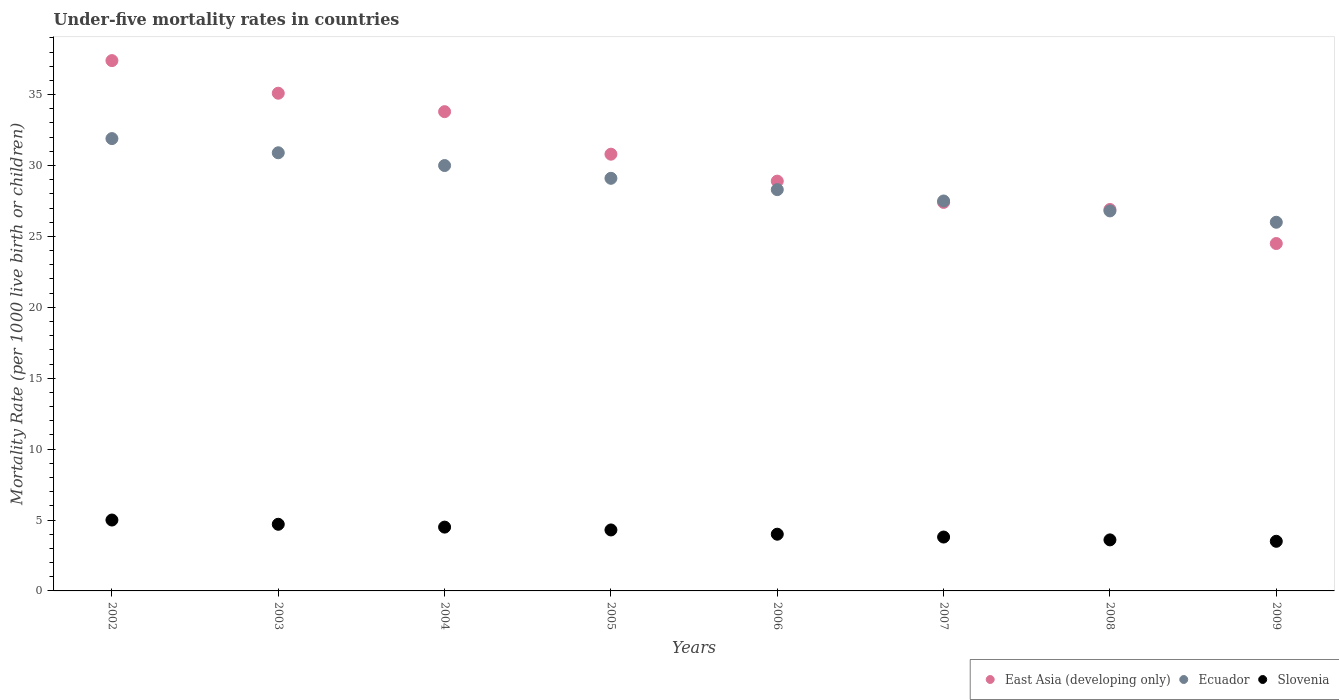How many different coloured dotlines are there?
Ensure brevity in your answer.  3. Is the number of dotlines equal to the number of legend labels?
Keep it short and to the point. Yes. What is the under-five mortality rate in East Asia (developing only) in 2002?
Your response must be concise. 37.4. Across all years, what is the maximum under-five mortality rate in Slovenia?
Offer a very short reply. 5. What is the total under-five mortality rate in Ecuador in the graph?
Offer a very short reply. 230.5. What is the difference between the under-five mortality rate in East Asia (developing only) in 2003 and that in 2005?
Your response must be concise. 4.3. What is the average under-five mortality rate in Ecuador per year?
Provide a succinct answer. 28.81. In the year 2006, what is the difference between the under-five mortality rate in East Asia (developing only) and under-five mortality rate in Slovenia?
Offer a very short reply. 24.9. In how many years, is the under-five mortality rate in East Asia (developing only) greater than 14?
Your response must be concise. 8. What is the ratio of the under-five mortality rate in Ecuador in 2002 to that in 2009?
Provide a succinct answer. 1.23. What is the difference between the highest and the second highest under-five mortality rate in Slovenia?
Give a very brief answer. 0.3. What is the difference between the highest and the lowest under-five mortality rate in Slovenia?
Make the answer very short. 1.5. Is the under-five mortality rate in Ecuador strictly less than the under-five mortality rate in East Asia (developing only) over the years?
Give a very brief answer. No. Are the values on the major ticks of Y-axis written in scientific E-notation?
Keep it short and to the point. No. Does the graph contain any zero values?
Make the answer very short. No. Does the graph contain grids?
Your response must be concise. No. How many legend labels are there?
Make the answer very short. 3. How are the legend labels stacked?
Your response must be concise. Horizontal. What is the title of the graph?
Ensure brevity in your answer.  Under-five mortality rates in countries. What is the label or title of the X-axis?
Your answer should be compact. Years. What is the label or title of the Y-axis?
Provide a short and direct response. Mortality Rate (per 1000 live birth or children). What is the Mortality Rate (per 1000 live birth or children) in East Asia (developing only) in 2002?
Your answer should be very brief. 37.4. What is the Mortality Rate (per 1000 live birth or children) of Ecuador in 2002?
Provide a short and direct response. 31.9. What is the Mortality Rate (per 1000 live birth or children) of East Asia (developing only) in 2003?
Ensure brevity in your answer.  35.1. What is the Mortality Rate (per 1000 live birth or children) of Ecuador in 2003?
Give a very brief answer. 30.9. What is the Mortality Rate (per 1000 live birth or children) in Slovenia in 2003?
Offer a terse response. 4.7. What is the Mortality Rate (per 1000 live birth or children) of East Asia (developing only) in 2004?
Your response must be concise. 33.8. What is the Mortality Rate (per 1000 live birth or children) of Slovenia in 2004?
Your response must be concise. 4.5. What is the Mortality Rate (per 1000 live birth or children) in East Asia (developing only) in 2005?
Offer a terse response. 30.8. What is the Mortality Rate (per 1000 live birth or children) of Ecuador in 2005?
Keep it short and to the point. 29.1. What is the Mortality Rate (per 1000 live birth or children) in East Asia (developing only) in 2006?
Your answer should be very brief. 28.9. What is the Mortality Rate (per 1000 live birth or children) of Ecuador in 2006?
Make the answer very short. 28.3. What is the Mortality Rate (per 1000 live birth or children) in East Asia (developing only) in 2007?
Offer a terse response. 27.4. What is the Mortality Rate (per 1000 live birth or children) in Ecuador in 2007?
Give a very brief answer. 27.5. What is the Mortality Rate (per 1000 live birth or children) of Slovenia in 2007?
Offer a very short reply. 3.8. What is the Mortality Rate (per 1000 live birth or children) of East Asia (developing only) in 2008?
Ensure brevity in your answer.  26.9. What is the Mortality Rate (per 1000 live birth or children) of Ecuador in 2008?
Ensure brevity in your answer.  26.8. What is the Mortality Rate (per 1000 live birth or children) in East Asia (developing only) in 2009?
Your answer should be compact. 24.5. Across all years, what is the maximum Mortality Rate (per 1000 live birth or children) of East Asia (developing only)?
Make the answer very short. 37.4. Across all years, what is the maximum Mortality Rate (per 1000 live birth or children) in Ecuador?
Provide a succinct answer. 31.9. Across all years, what is the minimum Mortality Rate (per 1000 live birth or children) of East Asia (developing only)?
Offer a very short reply. 24.5. What is the total Mortality Rate (per 1000 live birth or children) of East Asia (developing only) in the graph?
Ensure brevity in your answer.  244.8. What is the total Mortality Rate (per 1000 live birth or children) in Ecuador in the graph?
Ensure brevity in your answer.  230.5. What is the total Mortality Rate (per 1000 live birth or children) of Slovenia in the graph?
Your response must be concise. 33.4. What is the difference between the Mortality Rate (per 1000 live birth or children) in Slovenia in 2002 and that in 2003?
Provide a succinct answer. 0.3. What is the difference between the Mortality Rate (per 1000 live birth or children) in East Asia (developing only) in 2002 and that in 2004?
Your answer should be compact. 3.6. What is the difference between the Mortality Rate (per 1000 live birth or children) in Ecuador in 2002 and that in 2004?
Your answer should be very brief. 1.9. What is the difference between the Mortality Rate (per 1000 live birth or children) of Slovenia in 2002 and that in 2005?
Ensure brevity in your answer.  0.7. What is the difference between the Mortality Rate (per 1000 live birth or children) in Ecuador in 2002 and that in 2006?
Give a very brief answer. 3.6. What is the difference between the Mortality Rate (per 1000 live birth or children) of Slovenia in 2002 and that in 2006?
Provide a short and direct response. 1. What is the difference between the Mortality Rate (per 1000 live birth or children) of East Asia (developing only) in 2002 and that in 2007?
Provide a succinct answer. 10. What is the difference between the Mortality Rate (per 1000 live birth or children) in Ecuador in 2002 and that in 2007?
Your answer should be very brief. 4.4. What is the difference between the Mortality Rate (per 1000 live birth or children) of East Asia (developing only) in 2002 and that in 2008?
Your answer should be compact. 10.5. What is the difference between the Mortality Rate (per 1000 live birth or children) in Ecuador in 2002 and that in 2009?
Provide a short and direct response. 5.9. What is the difference between the Mortality Rate (per 1000 live birth or children) of Ecuador in 2003 and that in 2004?
Your answer should be compact. 0.9. What is the difference between the Mortality Rate (per 1000 live birth or children) of Slovenia in 2003 and that in 2005?
Provide a short and direct response. 0.4. What is the difference between the Mortality Rate (per 1000 live birth or children) in East Asia (developing only) in 2003 and that in 2006?
Make the answer very short. 6.2. What is the difference between the Mortality Rate (per 1000 live birth or children) in Ecuador in 2003 and that in 2006?
Provide a succinct answer. 2.6. What is the difference between the Mortality Rate (per 1000 live birth or children) in Slovenia in 2003 and that in 2006?
Your answer should be very brief. 0.7. What is the difference between the Mortality Rate (per 1000 live birth or children) of East Asia (developing only) in 2003 and that in 2007?
Offer a terse response. 7.7. What is the difference between the Mortality Rate (per 1000 live birth or children) of Slovenia in 2003 and that in 2007?
Keep it short and to the point. 0.9. What is the difference between the Mortality Rate (per 1000 live birth or children) of East Asia (developing only) in 2003 and that in 2008?
Make the answer very short. 8.2. What is the difference between the Mortality Rate (per 1000 live birth or children) of Slovenia in 2003 and that in 2008?
Your answer should be compact. 1.1. What is the difference between the Mortality Rate (per 1000 live birth or children) in Ecuador in 2003 and that in 2009?
Your response must be concise. 4.9. What is the difference between the Mortality Rate (per 1000 live birth or children) of East Asia (developing only) in 2004 and that in 2005?
Your answer should be very brief. 3. What is the difference between the Mortality Rate (per 1000 live birth or children) of Slovenia in 2004 and that in 2005?
Offer a terse response. 0.2. What is the difference between the Mortality Rate (per 1000 live birth or children) in East Asia (developing only) in 2004 and that in 2006?
Your response must be concise. 4.9. What is the difference between the Mortality Rate (per 1000 live birth or children) in Ecuador in 2004 and that in 2006?
Your answer should be compact. 1.7. What is the difference between the Mortality Rate (per 1000 live birth or children) in Ecuador in 2004 and that in 2007?
Provide a short and direct response. 2.5. What is the difference between the Mortality Rate (per 1000 live birth or children) in East Asia (developing only) in 2004 and that in 2008?
Offer a very short reply. 6.9. What is the difference between the Mortality Rate (per 1000 live birth or children) in Ecuador in 2004 and that in 2008?
Your answer should be very brief. 3.2. What is the difference between the Mortality Rate (per 1000 live birth or children) of Slovenia in 2004 and that in 2009?
Offer a terse response. 1. What is the difference between the Mortality Rate (per 1000 live birth or children) in Slovenia in 2005 and that in 2006?
Your answer should be compact. 0.3. What is the difference between the Mortality Rate (per 1000 live birth or children) in East Asia (developing only) in 2005 and that in 2008?
Your answer should be compact. 3.9. What is the difference between the Mortality Rate (per 1000 live birth or children) of Slovenia in 2005 and that in 2008?
Provide a short and direct response. 0.7. What is the difference between the Mortality Rate (per 1000 live birth or children) in East Asia (developing only) in 2005 and that in 2009?
Your response must be concise. 6.3. What is the difference between the Mortality Rate (per 1000 live birth or children) of Slovenia in 2005 and that in 2009?
Offer a very short reply. 0.8. What is the difference between the Mortality Rate (per 1000 live birth or children) of Slovenia in 2006 and that in 2007?
Your answer should be very brief. 0.2. What is the difference between the Mortality Rate (per 1000 live birth or children) in Ecuador in 2006 and that in 2008?
Offer a terse response. 1.5. What is the difference between the Mortality Rate (per 1000 live birth or children) of East Asia (developing only) in 2006 and that in 2009?
Give a very brief answer. 4.4. What is the difference between the Mortality Rate (per 1000 live birth or children) in Ecuador in 2007 and that in 2009?
Your answer should be compact. 1.5. What is the difference between the Mortality Rate (per 1000 live birth or children) in Slovenia in 2007 and that in 2009?
Give a very brief answer. 0.3. What is the difference between the Mortality Rate (per 1000 live birth or children) of East Asia (developing only) in 2008 and that in 2009?
Give a very brief answer. 2.4. What is the difference between the Mortality Rate (per 1000 live birth or children) in Slovenia in 2008 and that in 2009?
Your answer should be compact. 0.1. What is the difference between the Mortality Rate (per 1000 live birth or children) of East Asia (developing only) in 2002 and the Mortality Rate (per 1000 live birth or children) of Slovenia in 2003?
Provide a succinct answer. 32.7. What is the difference between the Mortality Rate (per 1000 live birth or children) of Ecuador in 2002 and the Mortality Rate (per 1000 live birth or children) of Slovenia in 2003?
Provide a succinct answer. 27.2. What is the difference between the Mortality Rate (per 1000 live birth or children) of East Asia (developing only) in 2002 and the Mortality Rate (per 1000 live birth or children) of Slovenia in 2004?
Ensure brevity in your answer.  32.9. What is the difference between the Mortality Rate (per 1000 live birth or children) in Ecuador in 2002 and the Mortality Rate (per 1000 live birth or children) in Slovenia in 2004?
Keep it short and to the point. 27.4. What is the difference between the Mortality Rate (per 1000 live birth or children) in East Asia (developing only) in 2002 and the Mortality Rate (per 1000 live birth or children) in Ecuador in 2005?
Your answer should be very brief. 8.3. What is the difference between the Mortality Rate (per 1000 live birth or children) of East Asia (developing only) in 2002 and the Mortality Rate (per 1000 live birth or children) of Slovenia in 2005?
Keep it short and to the point. 33.1. What is the difference between the Mortality Rate (per 1000 live birth or children) in Ecuador in 2002 and the Mortality Rate (per 1000 live birth or children) in Slovenia in 2005?
Offer a very short reply. 27.6. What is the difference between the Mortality Rate (per 1000 live birth or children) in East Asia (developing only) in 2002 and the Mortality Rate (per 1000 live birth or children) in Ecuador in 2006?
Offer a very short reply. 9.1. What is the difference between the Mortality Rate (per 1000 live birth or children) in East Asia (developing only) in 2002 and the Mortality Rate (per 1000 live birth or children) in Slovenia in 2006?
Your response must be concise. 33.4. What is the difference between the Mortality Rate (per 1000 live birth or children) of Ecuador in 2002 and the Mortality Rate (per 1000 live birth or children) of Slovenia in 2006?
Provide a short and direct response. 27.9. What is the difference between the Mortality Rate (per 1000 live birth or children) in East Asia (developing only) in 2002 and the Mortality Rate (per 1000 live birth or children) in Slovenia in 2007?
Your answer should be very brief. 33.6. What is the difference between the Mortality Rate (per 1000 live birth or children) in Ecuador in 2002 and the Mortality Rate (per 1000 live birth or children) in Slovenia in 2007?
Your response must be concise. 28.1. What is the difference between the Mortality Rate (per 1000 live birth or children) of East Asia (developing only) in 2002 and the Mortality Rate (per 1000 live birth or children) of Slovenia in 2008?
Offer a terse response. 33.8. What is the difference between the Mortality Rate (per 1000 live birth or children) in Ecuador in 2002 and the Mortality Rate (per 1000 live birth or children) in Slovenia in 2008?
Make the answer very short. 28.3. What is the difference between the Mortality Rate (per 1000 live birth or children) in East Asia (developing only) in 2002 and the Mortality Rate (per 1000 live birth or children) in Ecuador in 2009?
Make the answer very short. 11.4. What is the difference between the Mortality Rate (per 1000 live birth or children) in East Asia (developing only) in 2002 and the Mortality Rate (per 1000 live birth or children) in Slovenia in 2009?
Provide a succinct answer. 33.9. What is the difference between the Mortality Rate (per 1000 live birth or children) of Ecuador in 2002 and the Mortality Rate (per 1000 live birth or children) of Slovenia in 2009?
Give a very brief answer. 28.4. What is the difference between the Mortality Rate (per 1000 live birth or children) of East Asia (developing only) in 2003 and the Mortality Rate (per 1000 live birth or children) of Slovenia in 2004?
Provide a succinct answer. 30.6. What is the difference between the Mortality Rate (per 1000 live birth or children) in Ecuador in 2003 and the Mortality Rate (per 1000 live birth or children) in Slovenia in 2004?
Offer a terse response. 26.4. What is the difference between the Mortality Rate (per 1000 live birth or children) of East Asia (developing only) in 2003 and the Mortality Rate (per 1000 live birth or children) of Slovenia in 2005?
Provide a succinct answer. 30.8. What is the difference between the Mortality Rate (per 1000 live birth or children) of Ecuador in 2003 and the Mortality Rate (per 1000 live birth or children) of Slovenia in 2005?
Give a very brief answer. 26.6. What is the difference between the Mortality Rate (per 1000 live birth or children) in East Asia (developing only) in 2003 and the Mortality Rate (per 1000 live birth or children) in Slovenia in 2006?
Keep it short and to the point. 31.1. What is the difference between the Mortality Rate (per 1000 live birth or children) of Ecuador in 2003 and the Mortality Rate (per 1000 live birth or children) of Slovenia in 2006?
Keep it short and to the point. 26.9. What is the difference between the Mortality Rate (per 1000 live birth or children) of East Asia (developing only) in 2003 and the Mortality Rate (per 1000 live birth or children) of Slovenia in 2007?
Make the answer very short. 31.3. What is the difference between the Mortality Rate (per 1000 live birth or children) in Ecuador in 2003 and the Mortality Rate (per 1000 live birth or children) in Slovenia in 2007?
Your answer should be very brief. 27.1. What is the difference between the Mortality Rate (per 1000 live birth or children) in East Asia (developing only) in 2003 and the Mortality Rate (per 1000 live birth or children) in Ecuador in 2008?
Your answer should be very brief. 8.3. What is the difference between the Mortality Rate (per 1000 live birth or children) of East Asia (developing only) in 2003 and the Mortality Rate (per 1000 live birth or children) of Slovenia in 2008?
Provide a succinct answer. 31.5. What is the difference between the Mortality Rate (per 1000 live birth or children) in Ecuador in 2003 and the Mortality Rate (per 1000 live birth or children) in Slovenia in 2008?
Provide a succinct answer. 27.3. What is the difference between the Mortality Rate (per 1000 live birth or children) in East Asia (developing only) in 2003 and the Mortality Rate (per 1000 live birth or children) in Ecuador in 2009?
Ensure brevity in your answer.  9.1. What is the difference between the Mortality Rate (per 1000 live birth or children) of East Asia (developing only) in 2003 and the Mortality Rate (per 1000 live birth or children) of Slovenia in 2009?
Ensure brevity in your answer.  31.6. What is the difference between the Mortality Rate (per 1000 live birth or children) of Ecuador in 2003 and the Mortality Rate (per 1000 live birth or children) of Slovenia in 2009?
Ensure brevity in your answer.  27.4. What is the difference between the Mortality Rate (per 1000 live birth or children) in East Asia (developing only) in 2004 and the Mortality Rate (per 1000 live birth or children) in Slovenia in 2005?
Give a very brief answer. 29.5. What is the difference between the Mortality Rate (per 1000 live birth or children) of Ecuador in 2004 and the Mortality Rate (per 1000 live birth or children) of Slovenia in 2005?
Your answer should be compact. 25.7. What is the difference between the Mortality Rate (per 1000 live birth or children) in East Asia (developing only) in 2004 and the Mortality Rate (per 1000 live birth or children) in Slovenia in 2006?
Keep it short and to the point. 29.8. What is the difference between the Mortality Rate (per 1000 live birth or children) of Ecuador in 2004 and the Mortality Rate (per 1000 live birth or children) of Slovenia in 2006?
Provide a short and direct response. 26. What is the difference between the Mortality Rate (per 1000 live birth or children) of East Asia (developing only) in 2004 and the Mortality Rate (per 1000 live birth or children) of Slovenia in 2007?
Give a very brief answer. 30. What is the difference between the Mortality Rate (per 1000 live birth or children) of Ecuador in 2004 and the Mortality Rate (per 1000 live birth or children) of Slovenia in 2007?
Your answer should be very brief. 26.2. What is the difference between the Mortality Rate (per 1000 live birth or children) in East Asia (developing only) in 2004 and the Mortality Rate (per 1000 live birth or children) in Ecuador in 2008?
Offer a very short reply. 7. What is the difference between the Mortality Rate (per 1000 live birth or children) of East Asia (developing only) in 2004 and the Mortality Rate (per 1000 live birth or children) of Slovenia in 2008?
Offer a terse response. 30.2. What is the difference between the Mortality Rate (per 1000 live birth or children) of Ecuador in 2004 and the Mortality Rate (per 1000 live birth or children) of Slovenia in 2008?
Provide a succinct answer. 26.4. What is the difference between the Mortality Rate (per 1000 live birth or children) of East Asia (developing only) in 2004 and the Mortality Rate (per 1000 live birth or children) of Slovenia in 2009?
Offer a terse response. 30.3. What is the difference between the Mortality Rate (per 1000 live birth or children) of East Asia (developing only) in 2005 and the Mortality Rate (per 1000 live birth or children) of Slovenia in 2006?
Give a very brief answer. 26.8. What is the difference between the Mortality Rate (per 1000 live birth or children) in Ecuador in 2005 and the Mortality Rate (per 1000 live birth or children) in Slovenia in 2006?
Offer a very short reply. 25.1. What is the difference between the Mortality Rate (per 1000 live birth or children) of East Asia (developing only) in 2005 and the Mortality Rate (per 1000 live birth or children) of Slovenia in 2007?
Give a very brief answer. 27. What is the difference between the Mortality Rate (per 1000 live birth or children) of Ecuador in 2005 and the Mortality Rate (per 1000 live birth or children) of Slovenia in 2007?
Give a very brief answer. 25.3. What is the difference between the Mortality Rate (per 1000 live birth or children) of East Asia (developing only) in 2005 and the Mortality Rate (per 1000 live birth or children) of Slovenia in 2008?
Your answer should be compact. 27.2. What is the difference between the Mortality Rate (per 1000 live birth or children) of East Asia (developing only) in 2005 and the Mortality Rate (per 1000 live birth or children) of Slovenia in 2009?
Give a very brief answer. 27.3. What is the difference between the Mortality Rate (per 1000 live birth or children) of Ecuador in 2005 and the Mortality Rate (per 1000 live birth or children) of Slovenia in 2009?
Ensure brevity in your answer.  25.6. What is the difference between the Mortality Rate (per 1000 live birth or children) in East Asia (developing only) in 2006 and the Mortality Rate (per 1000 live birth or children) in Slovenia in 2007?
Offer a terse response. 25.1. What is the difference between the Mortality Rate (per 1000 live birth or children) of Ecuador in 2006 and the Mortality Rate (per 1000 live birth or children) of Slovenia in 2007?
Keep it short and to the point. 24.5. What is the difference between the Mortality Rate (per 1000 live birth or children) in East Asia (developing only) in 2006 and the Mortality Rate (per 1000 live birth or children) in Ecuador in 2008?
Ensure brevity in your answer.  2.1. What is the difference between the Mortality Rate (per 1000 live birth or children) in East Asia (developing only) in 2006 and the Mortality Rate (per 1000 live birth or children) in Slovenia in 2008?
Make the answer very short. 25.3. What is the difference between the Mortality Rate (per 1000 live birth or children) in Ecuador in 2006 and the Mortality Rate (per 1000 live birth or children) in Slovenia in 2008?
Make the answer very short. 24.7. What is the difference between the Mortality Rate (per 1000 live birth or children) of East Asia (developing only) in 2006 and the Mortality Rate (per 1000 live birth or children) of Slovenia in 2009?
Offer a terse response. 25.4. What is the difference between the Mortality Rate (per 1000 live birth or children) in Ecuador in 2006 and the Mortality Rate (per 1000 live birth or children) in Slovenia in 2009?
Provide a succinct answer. 24.8. What is the difference between the Mortality Rate (per 1000 live birth or children) in East Asia (developing only) in 2007 and the Mortality Rate (per 1000 live birth or children) in Slovenia in 2008?
Your answer should be very brief. 23.8. What is the difference between the Mortality Rate (per 1000 live birth or children) of Ecuador in 2007 and the Mortality Rate (per 1000 live birth or children) of Slovenia in 2008?
Ensure brevity in your answer.  23.9. What is the difference between the Mortality Rate (per 1000 live birth or children) in East Asia (developing only) in 2007 and the Mortality Rate (per 1000 live birth or children) in Ecuador in 2009?
Provide a short and direct response. 1.4. What is the difference between the Mortality Rate (per 1000 live birth or children) of East Asia (developing only) in 2007 and the Mortality Rate (per 1000 live birth or children) of Slovenia in 2009?
Keep it short and to the point. 23.9. What is the difference between the Mortality Rate (per 1000 live birth or children) of East Asia (developing only) in 2008 and the Mortality Rate (per 1000 live birth or children) of Ecuador in 2009?
Ensure brevity in your answer.  0.9. What is the difference between the Mortality Rate (per 1000 live birth or children) in East Asia (developing only) in 2008 and the Mortality Rate (per 1000 live birth or children) in Slovenia in 2009?
Your response must be concise. 23.4. What is the difference between the Mortality Rate (per 1000 live birth or children) of Ecuador in 2008 and the Mortality Rate (per 1000 live birth or children) of Slovenia in 2009?
Provide a succinct answer. 23.3. What is the average Mortality Rate (per 1000 live birth or children) in East Asia (developing only) per year?
Offer a very short reply. 30.6. What is the average Mortality Rate (per 1000 live birth or children) in Ecuador per year?
Give a very brief answer. 28.81. What is the average Mortality Rate (per 1000 live birth or children) in Slovenia per year?
Your answer should be compact. 4.17. In the year 2002, what is the difference between the Mortality Rate (per 1000 live birth or children) of East Asia (developing only) and Mortality Rate (per 1000 live birth or children) of Slovenia?
Your answer should be very brief. 32.4. In the year 2002, what is the difference between the Mortality Rate (per 1000 live birth or children) in Ecuador and Mortality Rate (per 1000 live birth or children) in Slovenia?
Your response must be concise. 26.9. In the year 2003, what is the difference between the Mortality Rate (per 1000 live birth or children) of East Asia (developing only) and Mortality Rate (per 1000 live birth or children) of Slovenia?
Your response must be concise. 30.4. In the year 2003, what is the difference between the Mortality Rate (per 1000 live birth or children) in Ecuador and Mortality Rate (per 1000 live birth or children) in Slovenia?
Make the answer very short. 26.2. In the year 2004, what is the difference between the Mortality Rate (per 1000 live birth or children) of East Asia (developing only) and Mortality Rate (per 1000 live birth or children) of Slovenia?
Keep it short and to the point. 29.3. In the year 2005, what is the difference between the Mortality Rate (per 1000 live birth or children) in East Asia (developing only) and Mortality Rate (per 1000 live birth or children) in Ecuador?
Your answer should be very brief. 1.7. In the year 2005, what is the difference between the Mortality Rate (per 1000 live birth or children) in Ecuador and Mortality Rate (per 1000 live birth or children) in Slovenia?
Ensure brevity in your answer.  24.8. In the year 2006, what is the difference between the Mortality Rate (per 1000 live birth or children) of East Asia (developing only) and Mortality Rate (per 1000 live birth or children) of Ecuador?
Ensure brevity in your answer.  0.6. In the year 2006, what is the difference between the Mortality Rate (per 1000 live birth or children) in East Asia (developing only) and Mortality Rate (per 1000 live birth or children) in Slovenia?
Offer a terse response. 24.9. In the year 2006, what is the difference between the Mortality Rate (per 1000 live birth or children) in Ecuador and Mortality Rate (per 1000 live birth or children) in Slovenia?
Ensure brevity in your answer.  24.3. In the year 2007, what is the difference between the Mortality Rate (per 1000 live birth or children) in East Asia (developing only) and Mortality Rate (per 1000 live birth or children) in Ecuador?
Give a very brief answer. -0.1. In the year 2007, what is the difference between the Mortality Rate (per 1000 live birth or children) of East Asia (developing only) and Mortality Rate (per 1000 live birth or children) of Slovenia?
Make the answer very short. 23.6. In the year 2007, what is the difference between the Mortality Rate (per 1000 live birth or children) in Ecuador and Mortality Rate (per 1000 live birth or children) in Slovenia?
Make the answer very short. 23.7. In the year 2008, what is the difference between the Mortality Rate (per 1000 live birth or children) in East Asia (developing only) and Mortality Rate (per 1000 live birth or children) in Ecuador?
Provide a short and direct response. 0.1. In the year 2008, what is the difference between the Mortality Rate (per 1000 live birth or children) of East Asia (developing only) and Mortality Rate (per 1000 live birth or children) of Slovenia?
Make the answer very short. 23.3. In the year 2008, what is the difference between the Mortality Rate (per 1000 live birth or children) in Ecuador and Mortality Rate (per 1000 live birth or children) in Slovenia?
Make the answer very short. 23.2. What is the ratio of the Mortality Rate (per 1000 live birth or children) of East Asia (developing only) in 2002 to that in 2003?
Ensure brevity in your answer.  1.07. What is the ratio of the Mortality Rate (per 1000 live birth or children) of Ecuador in 2002 to that in 2003?
Your response must be concise. 1.03. What is the ratio of the Mortality Rate (per 1000 live birth or children) of Slovenia in 2002 to that in 2003?
Ensure brevity in your answer.  1.06. What is the ratio of the Mortality Rate (per 1000 live birth or children) in East Asia (developing only) in 2002 to that in 2004?
Provide a short and direct response. 1.11. What is the ratio of the Mortality Rate (per 1000 live birth or children) in Ecuador in 2002 to that in 2004?
Give a very brief answer. 1.06. What is the ratio of the Mortality Rate (per 1000 live birth or children) in Slovenia in 2002 to that in 2004?
Give a very brief answer. 1.11. What is the ratio of the Mortality Rate (per 1000 live birth or children) in East Asia (developing only) in 2002 to that in 2005?
Ensure brevity in your answer.  1.21. What is the ratio of the Mortality Rate (per 1000 live birth or children) in Ecuador in 2002 to that in 2005?
Your answer should be compact. 1.1. What is the ratio of the Mortality Rate (per 1000 live birth or children) in Slovenia in 2002 to that in 2005?
Your answer should be very brief. 1.16. What is the ratio of the Mortality Rate (per 1000 live birth or children) of East Asia (developing only) in 2002 to that in 2006?
Your answer should be very brief. 1.29. What is the ratio of the Mortality Rate (per 1000 live birth or children) of Ecuador in 2002 to that in 2006?
Offer a very short reply. 1.13. What is the ratio of the Mortality Rate (per 1000 live birth or children) in East Asia (developing only) in 2002 to that in 2007?
Keep it short and to the point. 1.36. What is the ratio of the Mortality Rate (per 1000 live birth or children) in Ecuador in 2002 to that in 2007?
Your response must be concise. 1.16. What is the ratio of the Mortality Rate (per 1000 live birth or children) in Slovenia in 2002 to that in 2007?
Your response must be concise. 1.32. What is the ratio of the Mortality Rate (per 1000 live birth or children) in East Asia (developing only) in 2002 to that in 2008?
Provide a succinct answer. 1.39. What is the ratio of the Mortality Rate (per 1000 live birth or children) of Ecuador in 2002 to that in 2008?
Provide a succinct answer. 1.19. What is the ratio of the Mortality Rate (per 1000 live birth or children) in Slovenia in 2002 to that in 2008?
Give a very brief answer. 1.39. What is the ratio of the Mortality Rate (per 1000 live birth or children) in East Asia (developing only) in 2002 to that in 2009?
Ensure brevity in your answer.  1.53. What is the ratio of the Mortality Rate (per 1000 live birth or children) of Ecuador in 2002 to that in 2009?
Provide a short and direct response. 1.23. What is the ratio of the Mortality Rate (per 1000 live birth or children) of Slovenia in 2002 to that in 2009?
Give a very brief answer. 1.43. What is the ratio of the Mortality Rate (per 1000 live birth or children) of East Asia (developing only) in 2003 to that in 2004?
Keep it short and to the point. 1.04. What is the ratio of the Mortality Rate (per 1000 live birth or children) in Ecuador in 2003 to that in 2004?
Provide a short and direct response. 1.03. What is the ratio of the Mortality Rate (per 1000 live birth or children) in Slovenia in 2003 to that in 2004?
Offer a very short reply. 1.04. What is the ratio of the Mortality Rate (per 1000 live birth or children) in East Asia (developing only) in 2003 to that in 2005?
Offer a very short reply. 1.14. What is the ratio of the Mortality Rate (per 1000 live birth or children) of Ecuador in 2003 to that in 2005?
Offer a terse response. 1.06. What is the ratio of the Mortality Rate (per 1000 live birth or children) in Slovenia in 2003 to that in 2005?
Ensure brevity in your answer.  1.09. What is the ratio of the Mortality Rate (per 1000 live birth or children) of East Asia (developing only) in 2003 to that in 2006?
Your answer should be very brief. 1.21. What is the ratio of the Mortality Rate (per 1000 live birth or children) in Ecuador in 2003 to that in 2006?
Provide a succinct answer. 1.09. What is the ratio of the Mortality Rate (per 1000 live birth or children) of Slovenia in 2003 to that in 2006?
Your answer should be compact. 1.18. What is the ratio of the Mortality Rate (per 1000 live birth or children) in East Asia (developing only) in 2003 to that in 2007?
Offer a terse response. 1.28. What is the ratio of the Mortality Rate (per 1000 live birth or children) of Ecuador in 2003 to that in 2007?
Ensure brevity in your answer.  1.12. What is the ratio of the Mortality Rate (per 1000 live birth or children) of Slovenia in 2003 to that in 2007?
Your answer should be very brief. 1.24. What is the ratio of the Mortality Rate (per 1000 live birth or children) in East Asia (developing only) in 2003 to that in 2008?
Your answer should be very brief. 1.3. What is the ratio of the Mortality Rate (per 1000 live birth or children) in Ecuador in 2003 to that in 2008?
Give a very brief answer. 1.15. What is the ratio of the Mortality Rate (per 1000 live birth or children) in Slovenia in 2003 to that in 2008?
Keep it short and to the point. 1.31. What is the ratio of the Mortality Rate (per 1000 live birth or children) in East Asia (developing only) in 2003 to that in 2009?
Provide a short and direct response. 1.43. What is the ratio of the Mortality Rate (per 1000 live birth or children) of Ecuador in 2003 to that in 2009?
Your answer should be compact. 1.19. What is the ratio of the Mortality Rate (per 1000 live birth or children) in Slovenia in 2003 to that in 2009?
Provide a succinct answer. 1.34. What is the ratio of the Mortality Rate (per 1000 live birth or children) of East Asia (developing only) in 2004 to that in 2005?
Ensure brevity in your answer.  1.1. What is the ratio of the Mortality Rate (per 1000 live birth or children) in Ecuador in 2004 to that in 2005?
Your answer should be very brief. 1.03. What is the ratio of the Mortality Rate (per 1000 live birth or children) of Slovenia in 2004 to that in 2005?
Make the answer very short. 1.05. What is the ratio of the Mortality Rate (per 1000 live birth or children) of East Asia (developing only) in 2004 to that in 2006?
Your response must be concise. 1.17. What is the ratio of the Mortality Rate (per 1000 live birth or children) in Ecuador in 2004 to that in 2006?
Your response must be concise. 1.06. What is the ratio of the Mortality Rate (per 1000 live birth or children) in Slovenia in 2004 to that in 2006?
Provide a succinct answer. 1.12. What is the ratio of the Mortality Rate (per 1000 live birth or children) of East Asia (developing only) in 2004 to that in 2007?
Offer a very short reply. 1.23. What is the ratio of the Mortality Rate (per 1000 live birth or children) of Slovenia in 2004 to that in 2007?
Provide a succinct answer. 1.18. What is the ratio of the Mortality Rate (per 1000 live birth or children) in East Asia (developing only) in 2004 to that in 2008?
Make the answer very short. 1.26. What is the ratio of the Mortality Rate (per 1000 live birth or children) of Ecuador in 2004 to that in 2008?
Give a very brief answer. 1.12. What is the ratio of the Mortality Rate (per 1000 live birth or children) of Slovenia in 2004 to that in 2008?
Ensure brevity in your answer.  1.25. What is the ratio of the Mortality Rate (per 1000 live birth or children) in East Asia (developing only) in 2004 to that in 2009?
Your response must be concise. 1.38. What is the ratio of the Mortality Rate (per 1000 live birth or children) of Ecuador in 2004 to that in 2009?
Your answer should be compact. 1.15. What is the ratio of the Mortality Rate (per 1000 live birth or children) in East Asia (developing only) in 2005 to that in 2006?
Make the answer very short. 1.07. What is the ratio of the Mortality Rate (per 1000 live birth or children) in Ecuador in 2005 to that in 2006?
Offer a terse response. 1.03. What is the ratio of the Mortality Rate (per 1000 live birth or children) of Slovenia in 2005 to that in 2006?
Ensure brevity in your answer.  1.07. What is the ratio of the Mortality Rate (per 1000 live birth or children) of East Asia (developing only) in 2005 to that in 2007?
Give a very brief answer. 1.12. What is the ratio of the Mortality Rate (per 1000 live birth or children) of Ecuador in 2005 to that in 2007?
Ensure brevity in your answer.  1.06. What is the ratio of the Mortality Rate (per 1000 live birth or children) in Slovenia in 2005 to that in 2007?
Provide a succinct answer. 1.13. What is the ratio of the Mortality Rate (per 1000 live birth or children) in East Asia (developing only) in 2005 to that in 2008?
Give a very brief answer. 1.15. What is the ratio of the Mortality Rate (per 1000 live birth or children) in Ecuador in 2005 to that in 2008?
Give a very brief answer. 1.09. What is the ratio of the Mortality Rate (per 1000 live birth or children) in Slovenia in 2005 to that in 2008?
Your response must be concise. 1.19. What is the ratio of the Mortality Rate (per 1000 live birth or children) in East Asia (developing only) in 2005 to that in 2009?
Provide a succinct answer. 1.26. What is the ratio of the Mortality Rate (per 1000 live birth or children) of Ecuador in 2005 to that in 2009?
Give a very brief answer. 1.12. What is the ratio of the Mortality Rate (per 1000 live birth or children) in Slovenia in 2005 to that in 2009?
Your response must be concise. 1.23. What is the ratio of the Mortality Rate (per 1000 live birth or children) in East Asia (developing only) in 2006 to that in 2007?
Ensure brevity in your answer.  1.05. What is the ratio of the Mortality Rate (per 1000 live birth or children) in Ecuador in 2006 to that in 2007?
Offer a very short reply. 1.03. What is the ratio of the Mortality Rate (per 1000 live birth or children) in Slovenia in 2006 to that in 2007?
Your answer should be very brief. 1.05. What is the ratio of the Mortality Rate (per 1000 live birth or children) in East Asia (developing only) in 2006 to that in 2008?
Ensure brevity in your answer.  1.07. What is the ratio of the Mortality Rate (per 1000 live birth or children) of Ecuador in 2006 to that in 2008?
Offer a very short reply. 1.06. What is the ratio of the Mortality Rate (per 1000 live birth or children) in Slovenia in 2006 to that in 2008?
Your answer should be very brief. 1.11. What is the ratio of the Mortality Rate (per 1000 live birth or children) of East Asia (developing only) in 2006 to that in 2009?
Give a very brief answer. 1.18. What is the ratio of the Mortality Rate (per 1000 live birth or children) of Ecuador in 2006 to that in 2009?
Give a very brief answer. 1.09. What is the ratio of the Mortality Rate (per 1000 live birth or children) of East Asia (developing only) in 2007 to that in 2008?
Offer a very short reply. 1.02. What is the ratio of the Mortality Rate (per 1000 live birth or children) in Ecuador in 2007 to that in 2008?
Offer a terse response. 1.03. What is the ratio of the Mortality Rate (per 1000 live birth or children) in Slovenia in 2007 to that in 2008?
Give a very brief answer. 1.06. What is the ratio of the Mortality Rate (per 1000 live birth or children) in East Asia (developing only) in 2007 to that in 2009?
Ensure brevity in your answer.  1.12. What is the ratio of the Mortality Rate (per 1000 live birth or children) in Ecuador in 2007 to that in 2009?
Your response must be concise. 1.06. What is the ratio of the Mortality Rate (per 1000 live birth or children) in Slovenia in 2007 to that in 2009?
Offer a terse response. 1.09. What is the ratio of the Mortality Rate (per 1000 live birth or children) of East Asia (developing only) in 2008 to that in 2009?
Provide a succinct answer. 1.1. What is the ratio of the Mortality Rate (per 1000 live birth or children) of Ecuador in 2008 to that in 2009?
Your response must be concise. 1.03. What is the ratio of the Mortality Rate (per 1000 live birth or children) of Slovenia in 2008 to that in 2009?
Offer a very short reply. 1.03. What is the difference between the highest and the second highest Mortality Rate (per 1000 live birth or children) of East Asia (developing only)?
Offer a very short reply. 2.3. What is the difference between the highest and the lowest Mortality Rate (per 1000 live birth or children) of East Asia (developing only)?
Offer a very short reply. 12.9. What is the difference between the highest and the lowest Mortality Rate (per 1000 live birth or children) in Slovenia?
Offer a terse response. 1.5. 